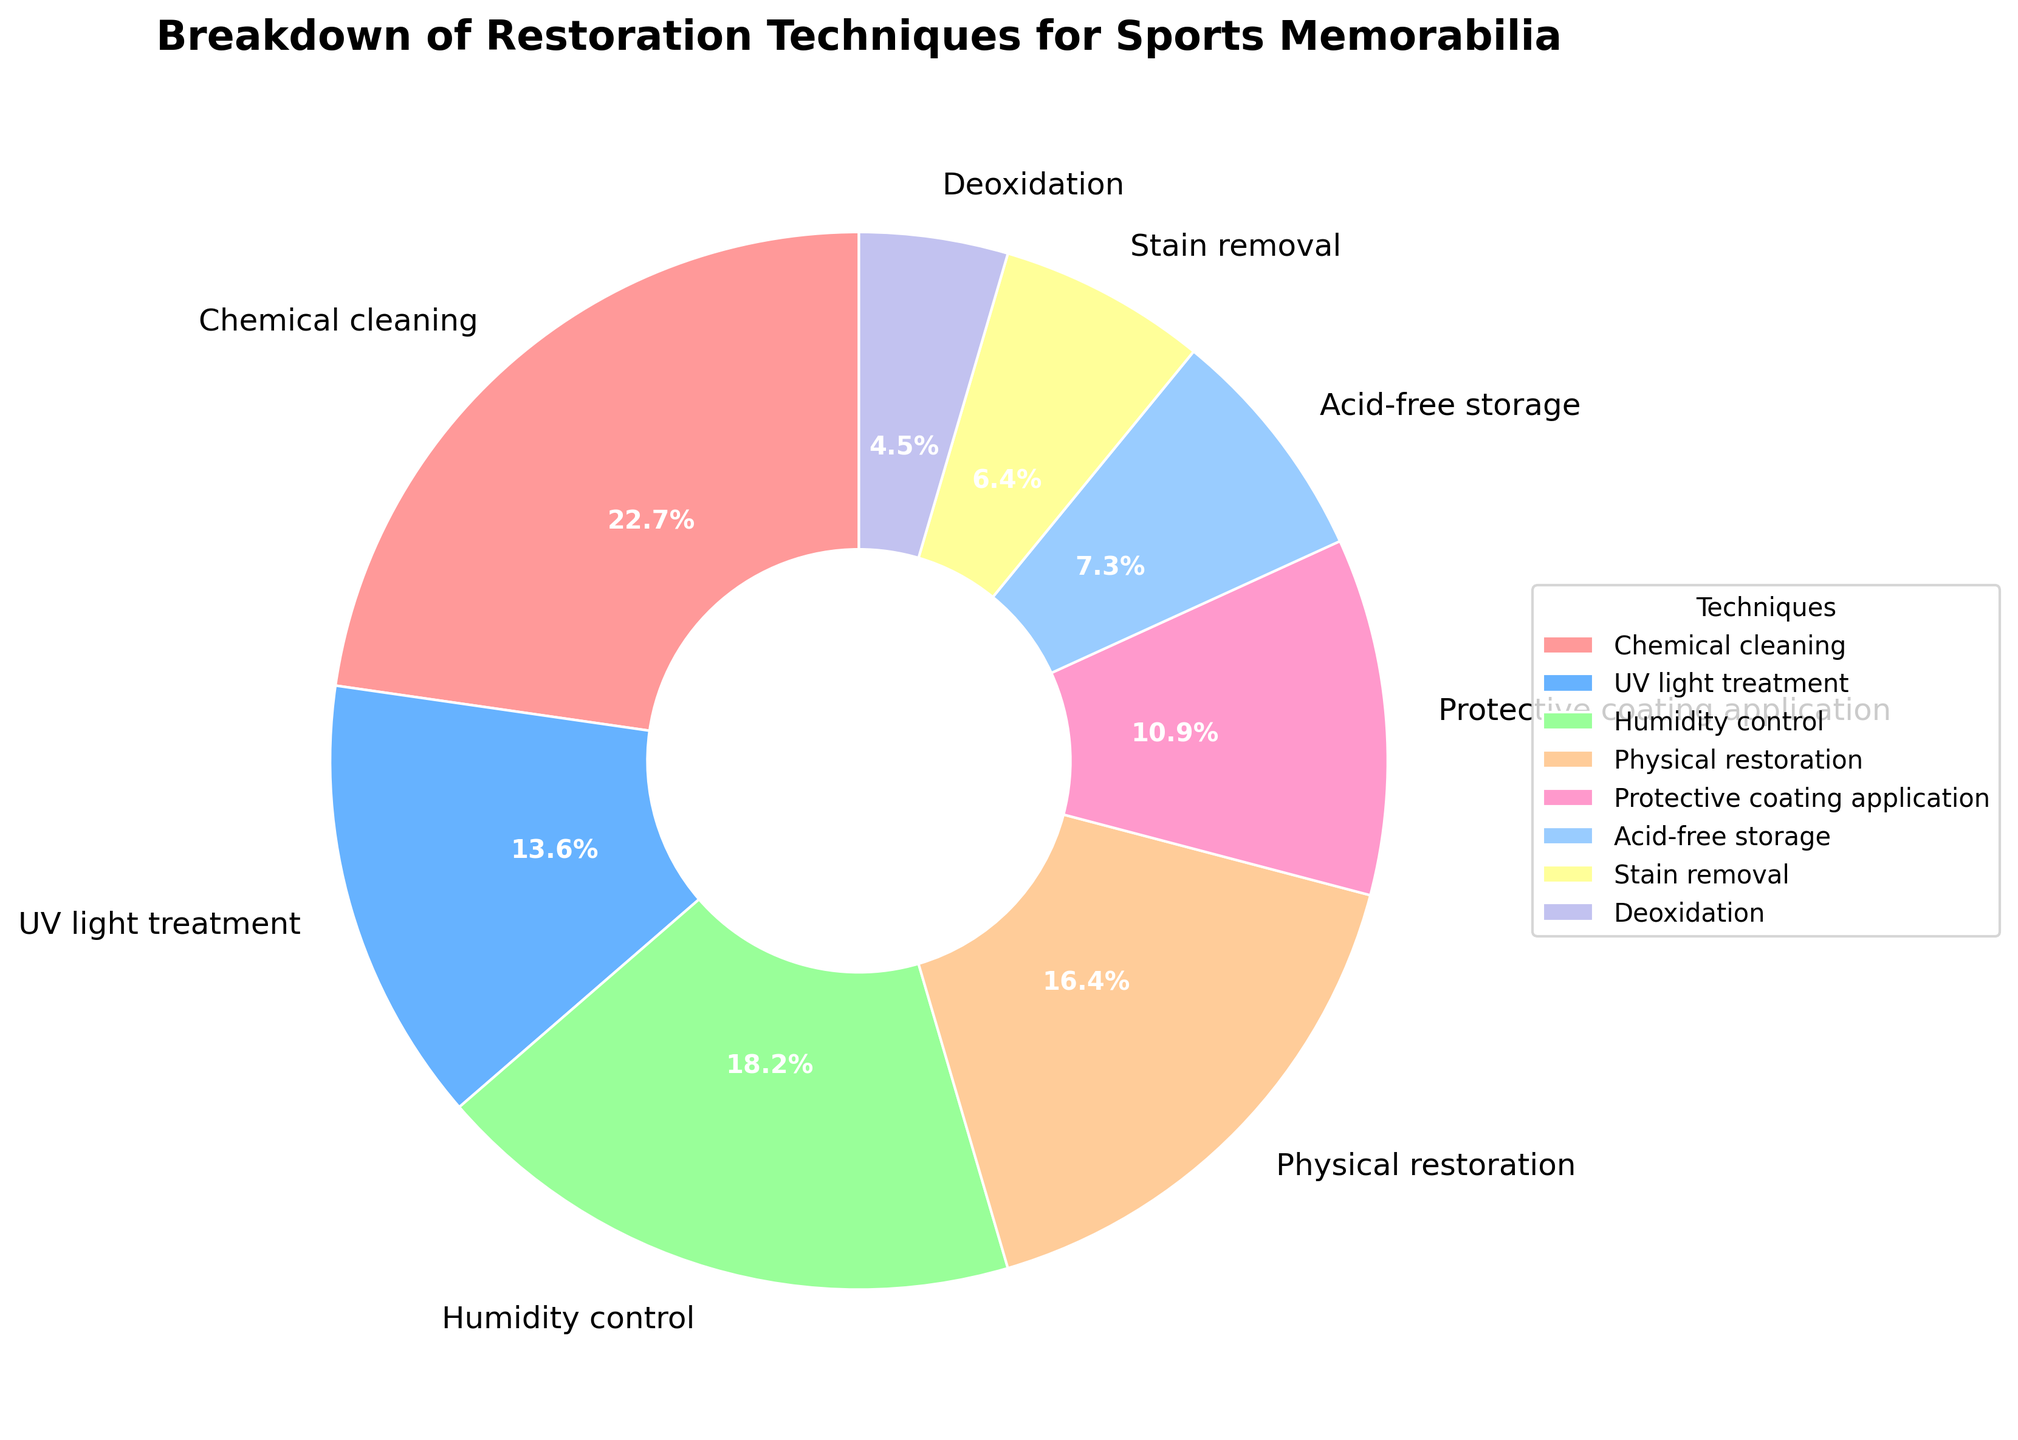What's the most used restoration technique? The pie chart shows the largest segment by size, which corresponds to the "Chemical cleaning" technique.
Answer: Chemical cleaning Which restoration technique is used the least? The smallest segment in the pie chart represents the "Deoxidation" technique.
Answer: Deoxidation Which technique is more widely used: UV light treatment or Humidity control? The pie chart segments for "UV light treatment" and "Humidity control" show that Humidity control is larger.
Answer: Humidity control What is the combined percentage for Chemical cleaning and Physical restoration? The respective percentages are 25% for Chemical cleaning and 18% for Physical restoration. Sum them together: 25% + 18% = 43%.
Answer: 43% Is Acid-free storage used more frequently than Stain removal? By comparing the two segments, Acid-free storage is 8%, and Stain removal is 7%, so Acid-free storage is used more frequently.
Answer: Yes What are the two least-used techniques together in terms of percentage? The least-used techniques are "Stain removal" (7%) and "Deoxidation" (5%). Summing these together gives 7% + 5% = 12%.
Answer: Stain removal and Deoxidation, 12% How much more frequently is Chemical cleaning used compared to Acid-free storage? Chemical cleaning accounts for 25%, and Acid-free storage accounts for 8%. The difference is 25% - 8% = 17%.
Answer: 17% What restoration techniques make up more than 50% of the total use combined? Adding up the most significant segments: Chemical cleaning (25%), Humidity control (20%), and Physical restoration (18%) gives 25% + 20% + 18% = 63%.
Answer: Chemical cleaning, Humidity control, Physical restoration How do Physical restoration and Protective coating application compare in usage? Physical restoration is 18%, while Protective coating application is 12%. Physical restoration is used more frequently than Protective coating application.
Answer: Physical restoration Which technique's percentage is closest to the average percentage of all techniques? To find the average, sum all percentages (25 + 15 + 20 + 18 + 12 + 8 + 7 + 5 = 110) and divide by the number of techniques (8): 110 / 8 ≈ 13.75%. The closest percentage is Protective coating application (12%).
Answer: Protective coating application 